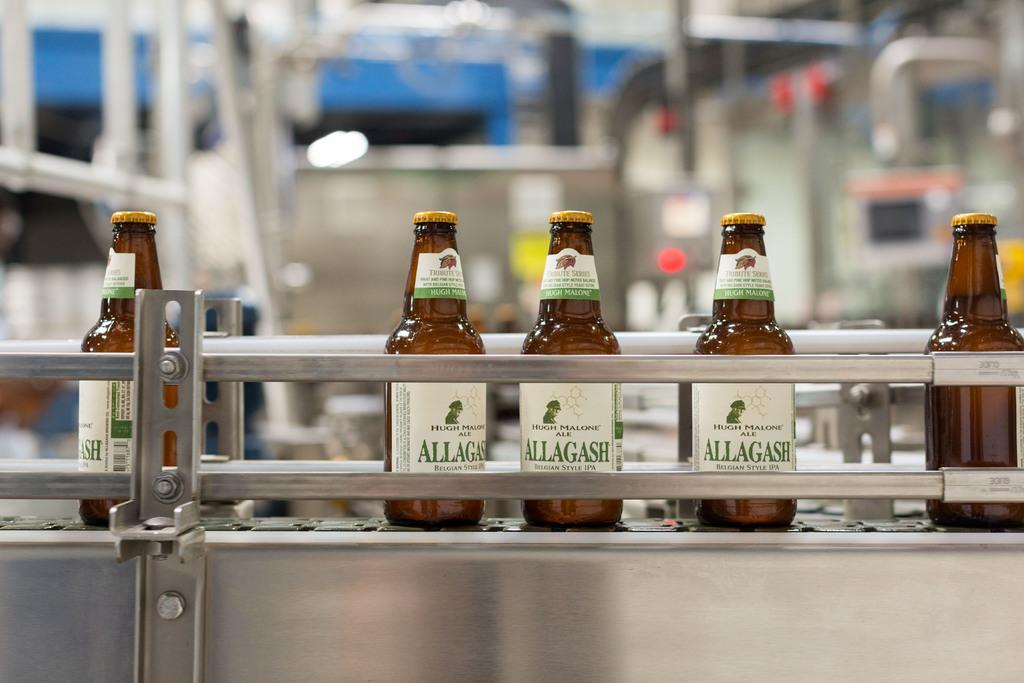<image>
Provide a brief description of the given image. Five beers labeled Allagash sit on a factory line. 